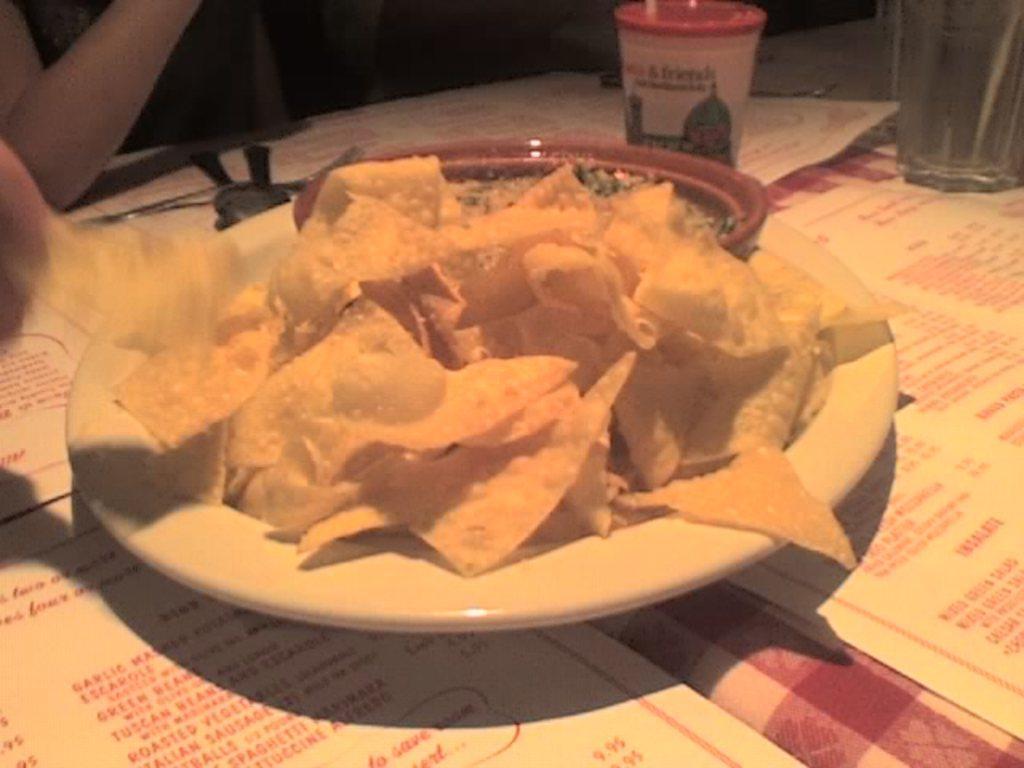Can you describe this image briefly? In this picture there is a woman who is sitting near to the table. On the table I can see the chips in a plate, a cup and water glass. 